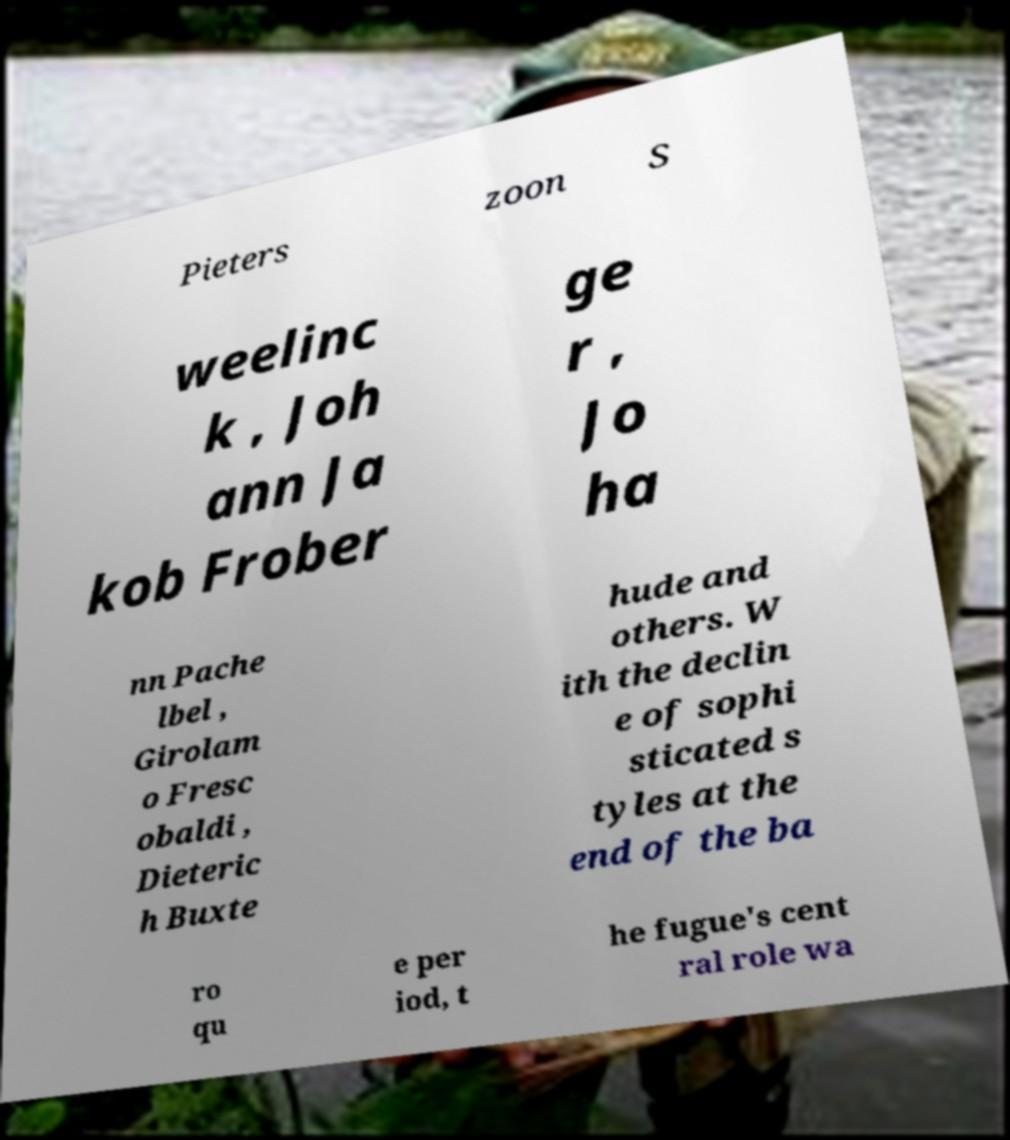There's text embedded in this image that I need extracted. Can you transcribe it verbatim? Pieters zoon S weelinc k , Joh ann Ja kob Frober ge r , Jo ha nn Pache lbel , Girolam o Fresc obaldi , Dieteric h Buxte hude and others. W ith the declin e of sophi sticated s tyles at the end of the ba ro qu e per iod, t he fugue's cent ral role wa 